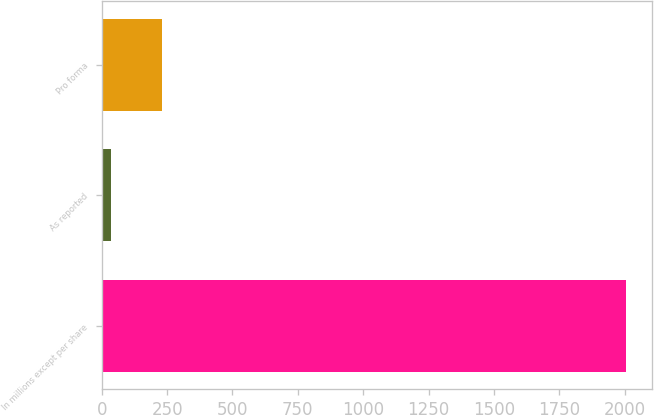<chart> <loc_0><loc_0><loc_500><loc_500><bar_chart><fcel>In millions except per share<fcel>As reported<fcel>Pro forma<nl><fcel>2004<fcel>35<fcel>231.9<nl></chart> 